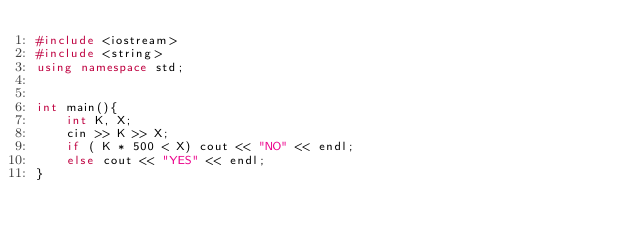<code> <loc_0><loc_0><loc_500><loc_500><_C++_>#include <iostream>
#include <string>
using namespace std;


int main(){
    int K, X;
    cin >> K >> X;
    if ( K * 500 < X) cout << "NO" << endl;
    else cout << "YES" << endl;
}</code> 